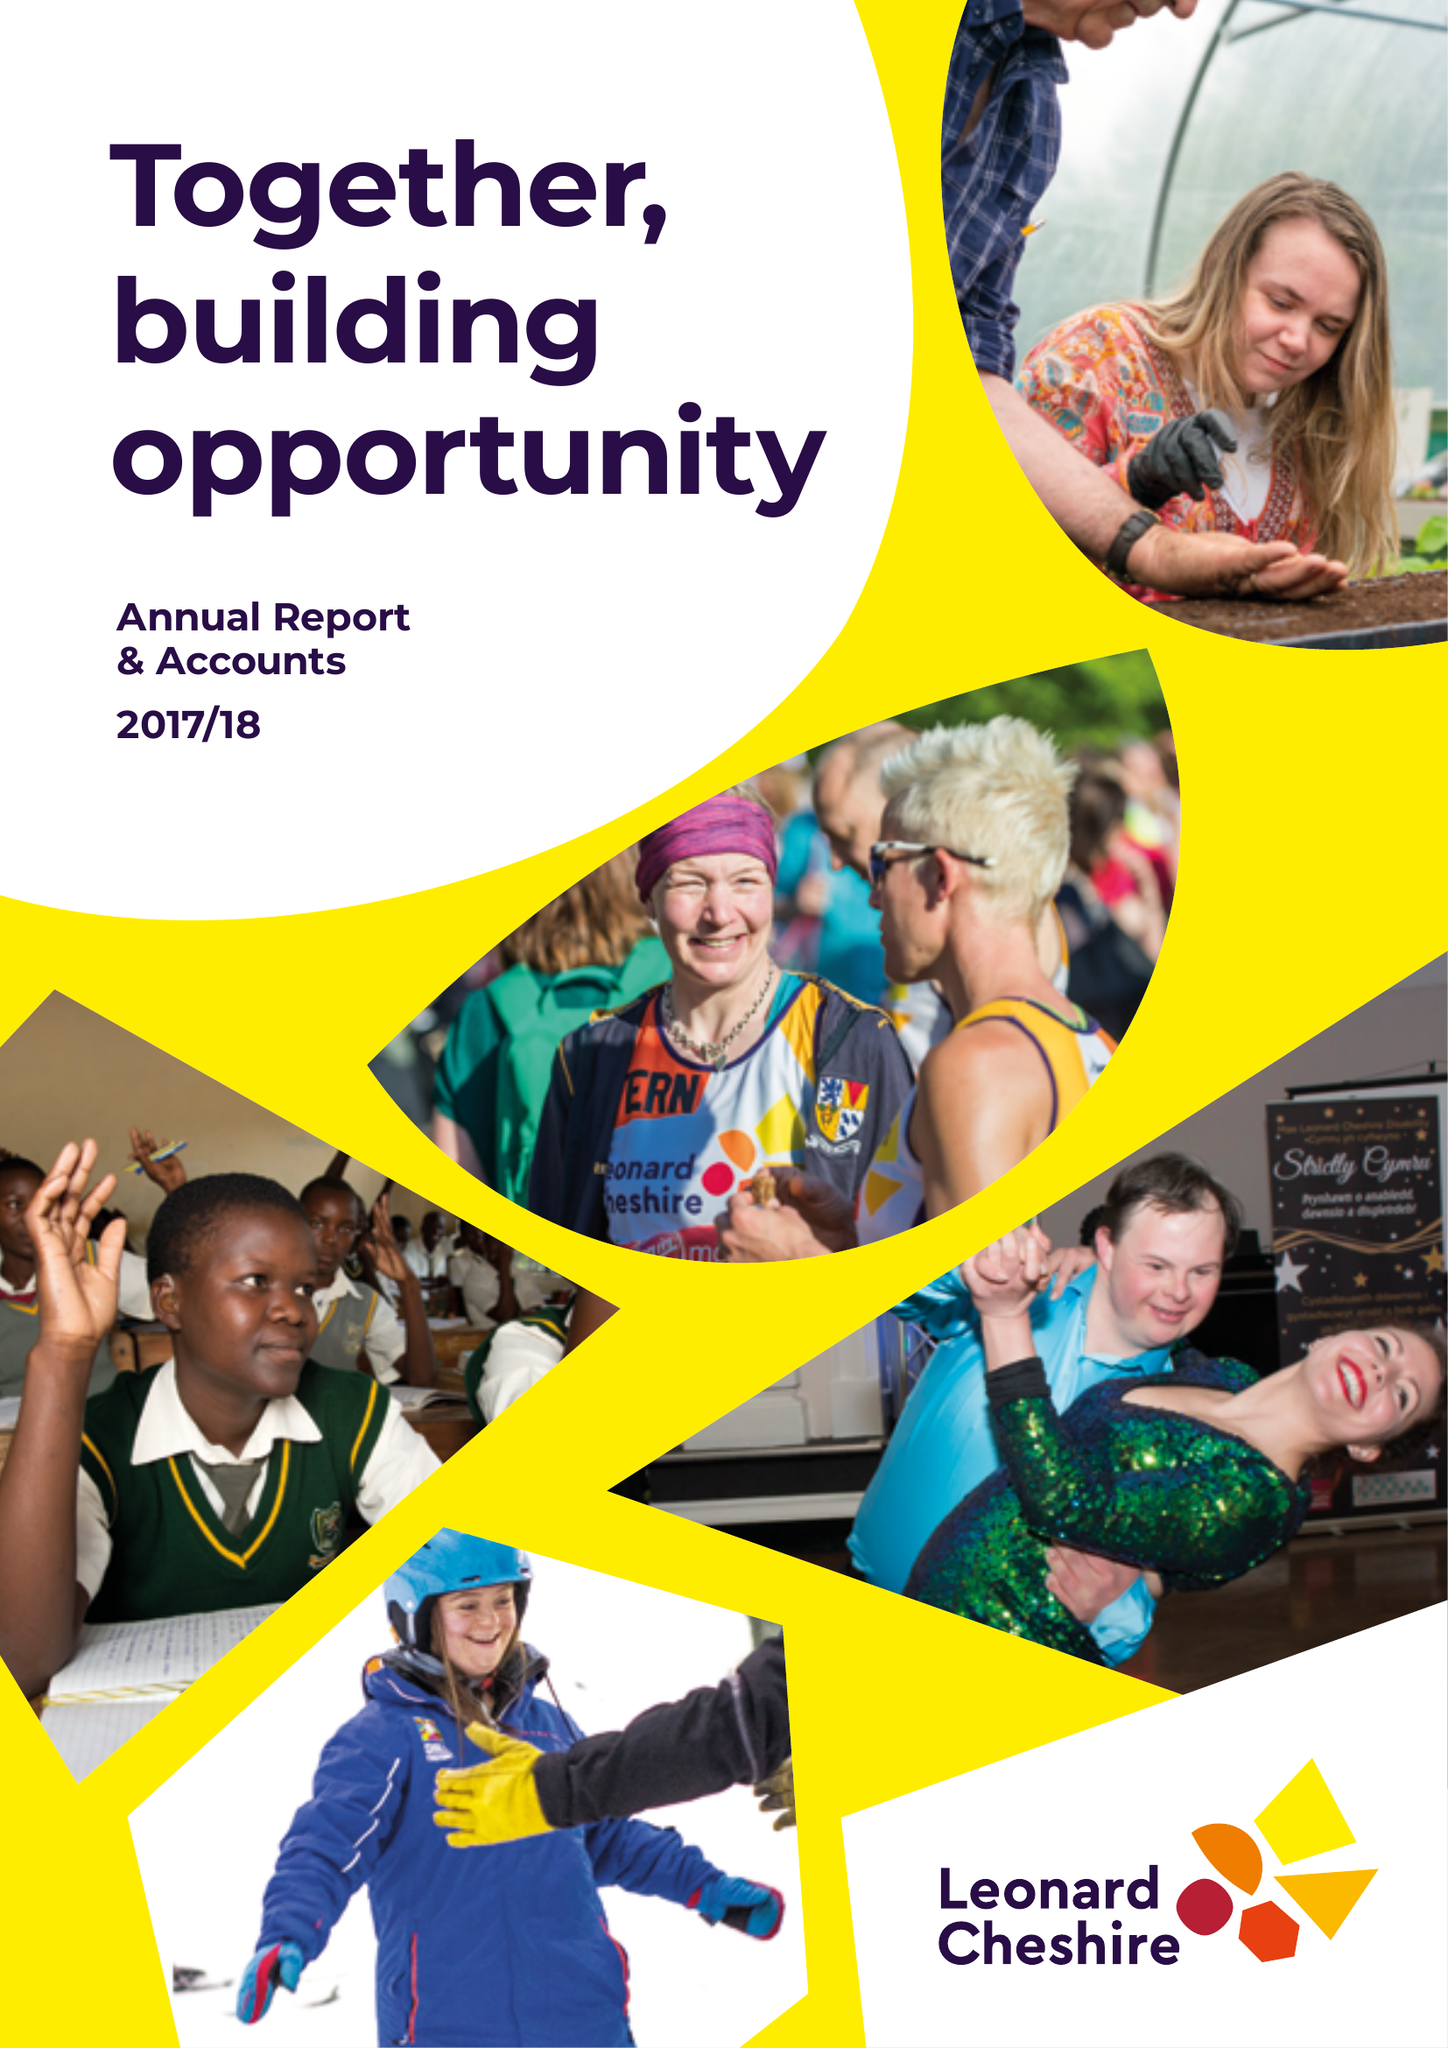What is the value for the income_annually_in_british_pounds?
Answer the question using a single word or phrase. 175895000.00 